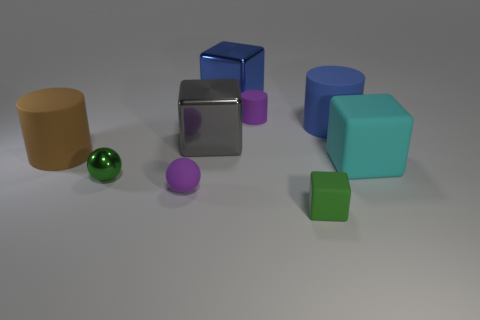Is the color of the cylinder to the left of the big blue shiny thing the same as the large matte cylinder that is to the right of the tiny green rubber thing?
Keep it short and to the point. No. There is a cyan matte object that is the same size as the gray block; what is its shape?
Offer a very short reply. Cube. Is there a small matte thing that has the same shape as the big gray thing?
Your answer should be very brief. Yes. Does the small purple object to the right of the large blue shiny block have the same material as the large cylinder that is to the right of the green matte block?
Make the answer very short. Yes. There is a small matte object that is the same color as the metal sphere; what is its shape?
Provide a short and direct response. Cube. What number of purple spheres have the same material as the big brown object?
Provide a short and direct response. 1. The tiny shiny sphere has what color?
Offer a very short reply. Green. There is a blue thing right of the tiny block; is its shape the same as the blue thing left of the green block?
Provide a succinct answer. No. There is a large metal thing that is in front of the purple matte cylinder; what is its color?
Ensure brevity in your answer.  Gray. Is the number of metallic things behind the large gray metal cube less than the number of green rubber cubes in front of the tiny cylinder?
Make the answer very short. No. 